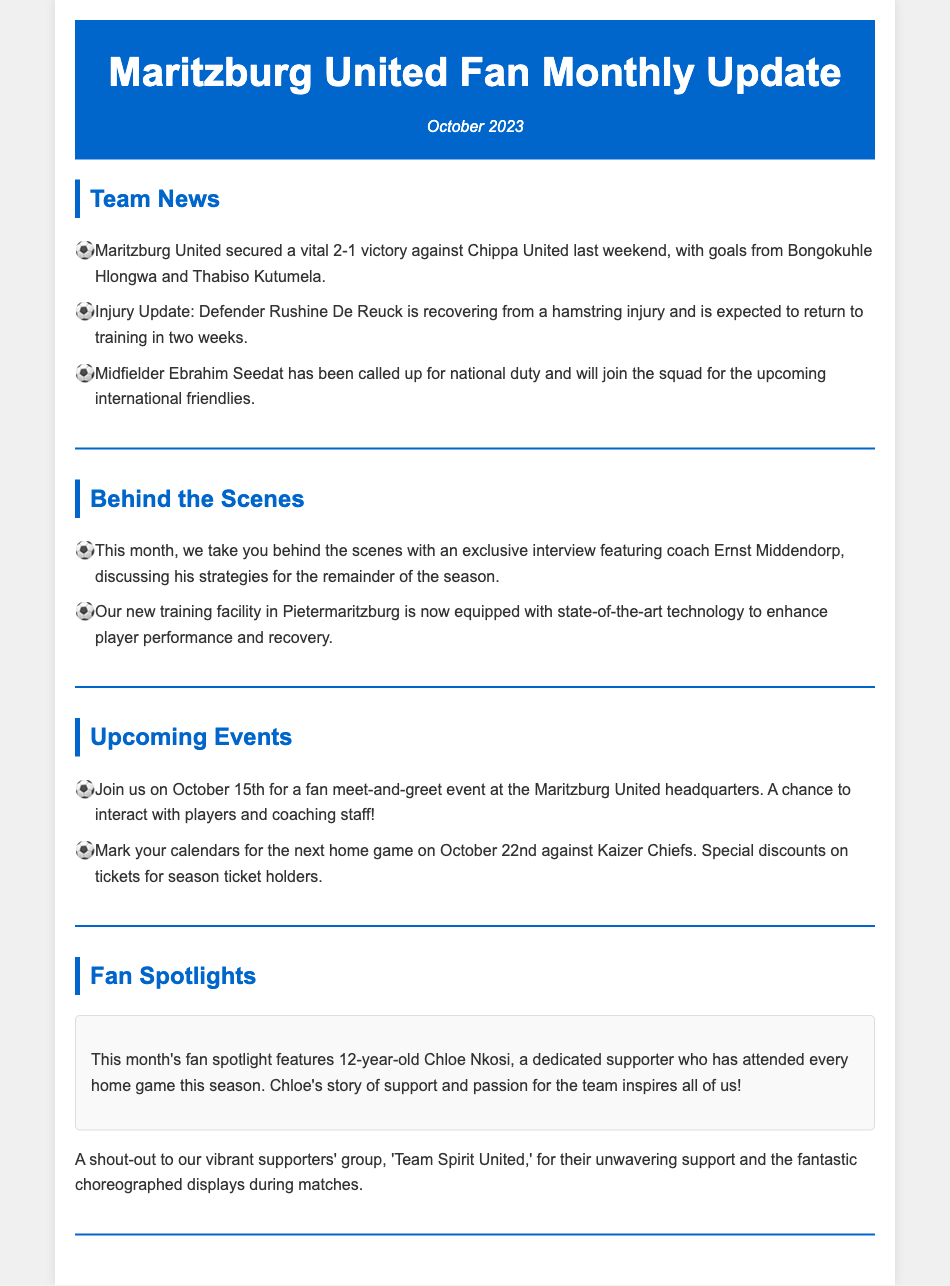What was the result of the recent match against Chippa United? The document states that Maritzburg United secured a vital 2-1 victory against Chippa United.
Answer: 2-1 Who scored the goals in the match against Chippa United? The document lists Bongokuhle Hlongwa and Thabiso Kutumela as the goal scorers.
Answer: Bongokuhle Hlongwa and Thabiso Kutumela When is Rushine De Reuck expected to return to training? The document mentions that he is recovering and expected to return in two weeks.
Answer: In two weeks What date is the fan meet-and-greet event scheduled? The document states the event will take place on October 15th.
Answer: October 15th Which team will Maritzburg United face at their next home game? The document indicates that they will play against Kaizer Chiefs.
Answer: Kaizer Chiefs What is the age of the featured fan spotlight member this month? Chloe Nkosi is identified as a 12-year-old supporter in the document.
Answer: 12 What type of technology has been added to the new training facility? The document mentions that it is equipped with state-of-the-art technology.
Answer: State-of-the-art technology Which supporters' group receives a shout-out in the newsletter? The document recognizes the supporters' group 'Team Spirit United'.
Answer: Team Spirit United What is the length of time Chloe Nkosi has attended every home game this season? The document states that Chloe has attended every home game this season.
Answer: This season 